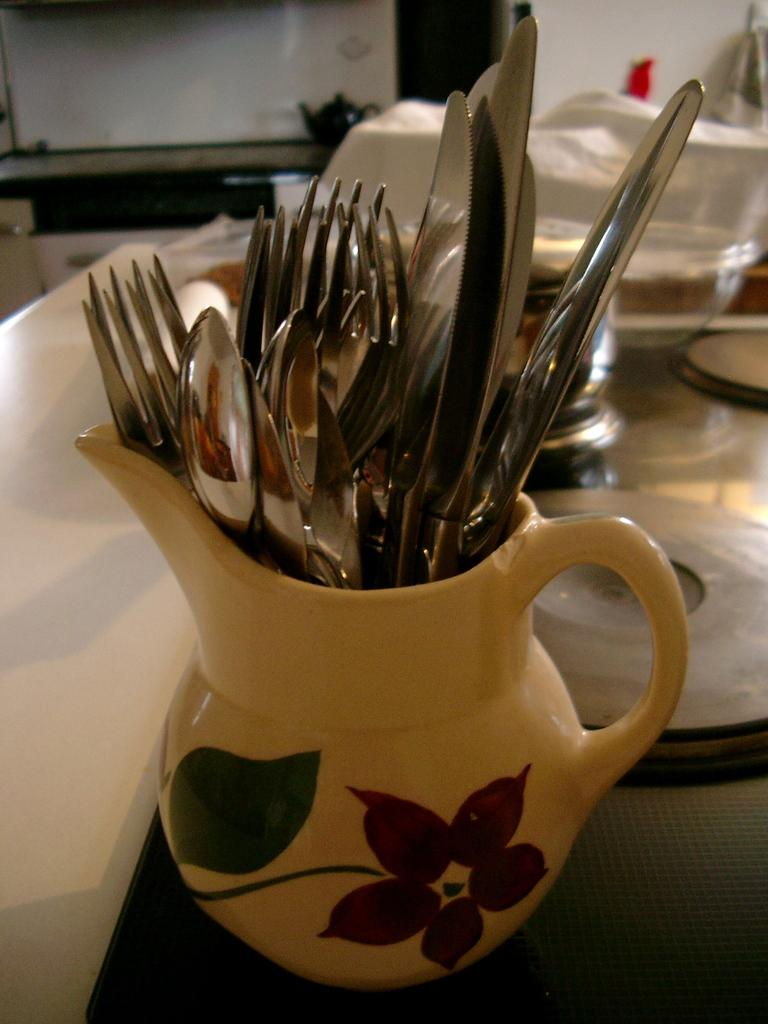What type of utensils can be seen in the image? There are forks, spoons, and knives in the image. How are the utensils arranged in the image? The forks, spoons, and knives are in a jug. What other tableware items are present in the image? There are plates and bowls in the image. Where are the plates and bowls located? The plates and bowls are on top of a table. Can you see any salt being sprinkled on the plates in the image? There is no salt visible in the image, and it does not show any action of sprinkling salt on the plates. 